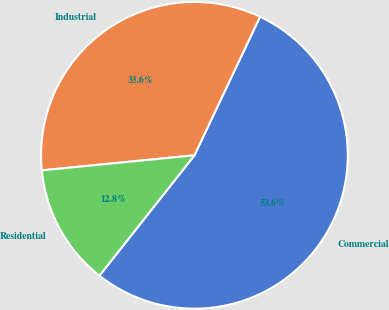Convert chart to OTSL. <chart><loc_0><loc_0><loc_500><loc_500><pie_chart><fcel>Commercial<fcel>Industrial<fcel>Residential<nl><fcel>53.6%<fcel>33.6%<fcel>12.8%<nl></chart> 